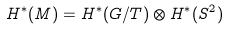Convert formula to latex. <formula><loc_0><loc_0><loc_500><loc_500>H ^ { * } ( M ) = H ^ { * } ( G / T ) \otimes H ^ { * } ( S ^ { 2 } )</formula> 